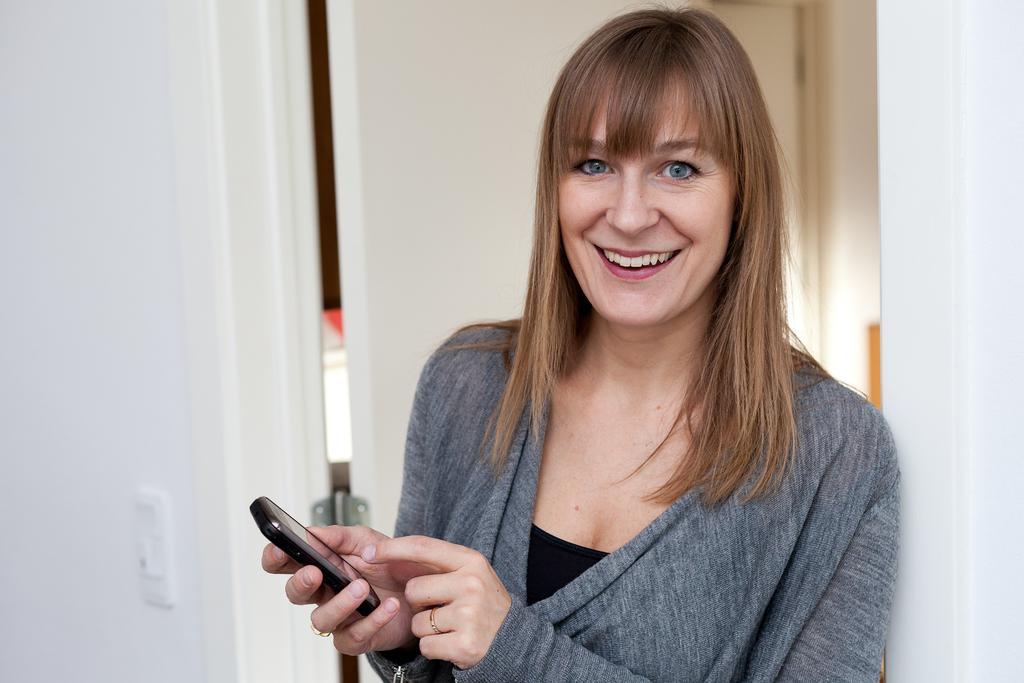Please provide a concise description of this image. On the right side of the image there is a lady standing and holding mobile in her hand. She is smiling. In the background there is a door and a wall. 